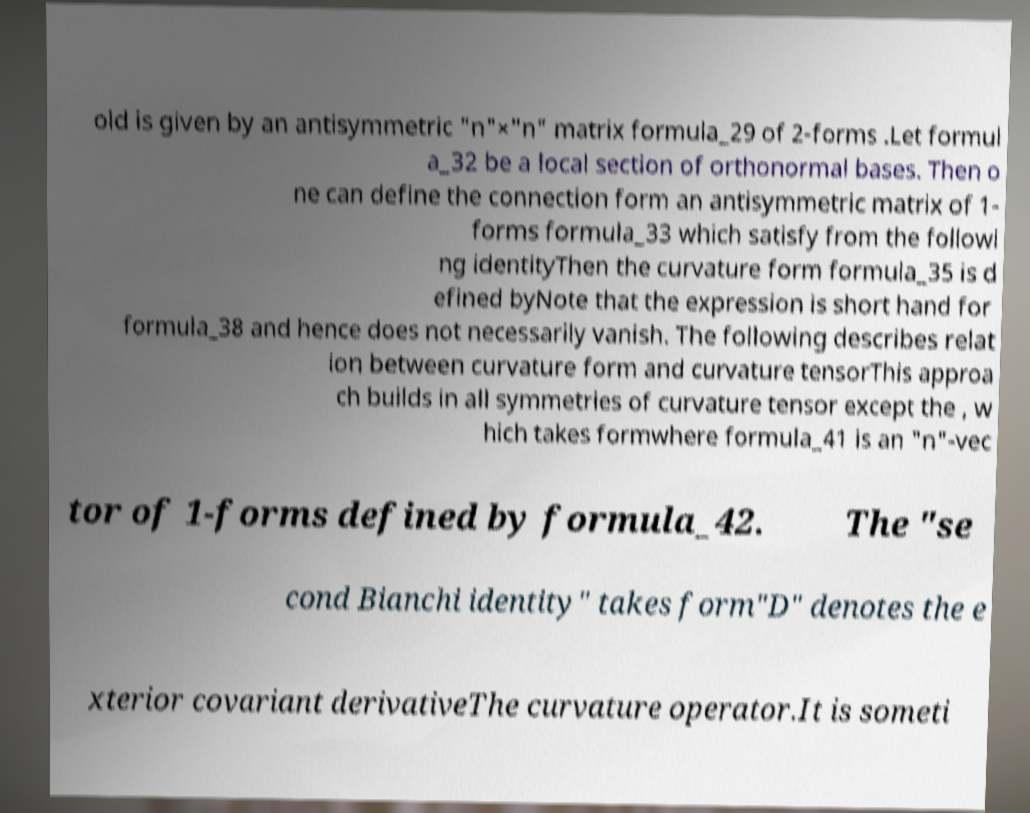Please identify and transcribe the text found in this image. old is given by an antisymmetric "n"×"n" matrix formula_29 of 2-forms .Let formul a_32 be a local section of orthonormal bases. Then o ne can define the connection form an antisymmetric matrix of 1- forms formula_33 which satisfy from the followi ng identityThen the curvature form formula_35 is d efined byNote that the expression is short hand for formula_38 and hence does not necessarily vanish. The following describes relat ion between curvature form and curvature tensorThis approa ch builds in all symmetries of curvature tensor except the , w hich takes formwhere formula_41 is an "n"-vec tor of 1-forms defined by formula_42. The "se cond Bianchi identity" takes form"D" denotes the e xterior covariant derivativeThe curvature operator.It is someti 